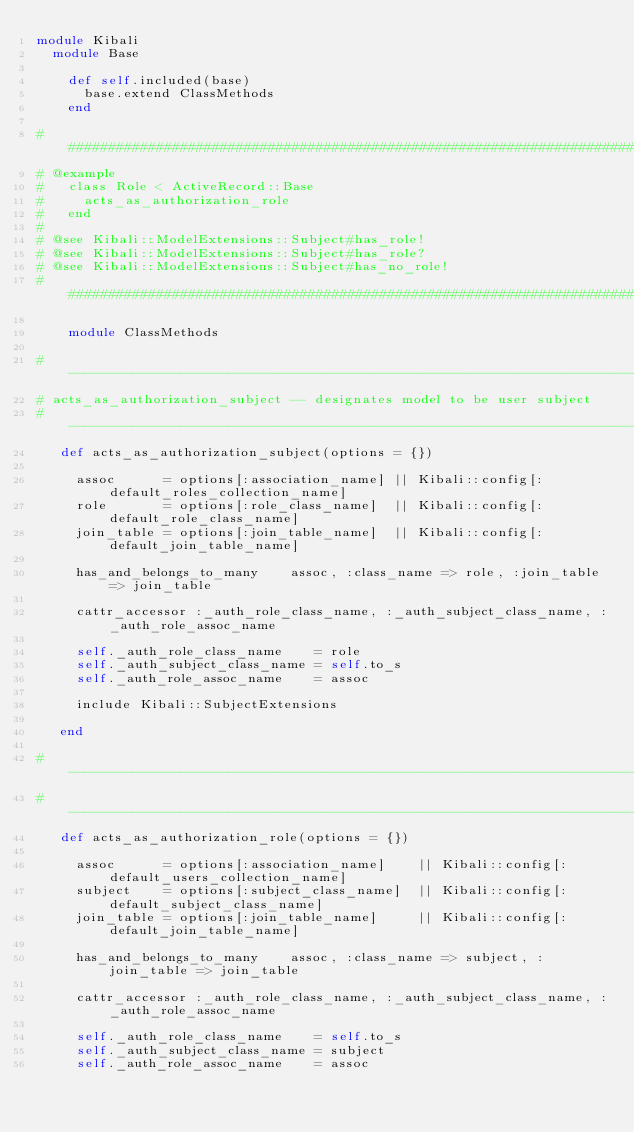Convert code to text. <code><loc_0><loc_0><loc_500><loc_500><_Ruby_>module Kibali
  module Base

    def self.included(base)
      base.extend ClassMethods
    end

# #############################################################################
# @example
#   class Role < ActiveRecord::Base
#     acts_as_authorization_role
#   end
#
# @see Kibali::ModelExtensions::Subject#has_role!
# @see Kibali::ModelExtensions::Subject#has_role?
# @see Kibali::ModelExtensions::Subject#has_no_role!
# #############################################################################

    module ClassMethods

# ------------------------------------------------------------------------
# acts_as_authorization_subject -- designates model to be user subject
# ------------------------------------------------------------------------
   def acts_as_authorization_subject(options = {})

     assoc      = options[:association_name] || Kibali::config[:default_roles_collection_name]
     role       = options[:role_class_name]  || Kibali::config[:default_role_class_name]
     join_table = options[:join_table_name]  || Kibali::config[:default_join_table_name]

     has_and_belongs_to_many    assoc, :class_name => role, :join_table => join_table

     cattr_accessor :_auth_role_class_name, :_auth_subject_class_name, :_auth_role_assoc_name

     self._auth_role_class_name    = role
     self._auth_subject_class_name = self.to_s
     self._auth_role_assoc_name    = assoc

     include Kibali::SubjectExtensions

   end

# ------------------------------------------------------------------------
# ------------------------------------------------------------------------
   def acts_as_authorization_role(options = {})

     assoc      = options[:association_name]    || Kibali::config[:default_users_collection_name]
     subject    = options[:subject_class_name]  || Kibali::config[:default_subject_class_name]
     join_table = options[:join_table_name]     || Kibali::config[:default_join_table_name]

     has_and_belongs_to_many    assoc, :class_name => subject, :join_table => join_table

     cattr_accessor :_auth_role_class_name, :_auth_subject_class_name, :_auth_role_assoc_name

     self._auth_role_class_name    = self.to_s
     self._auth_subject_class_name = subject
     self._auth_role_assoc_name    = assoc
</code> 